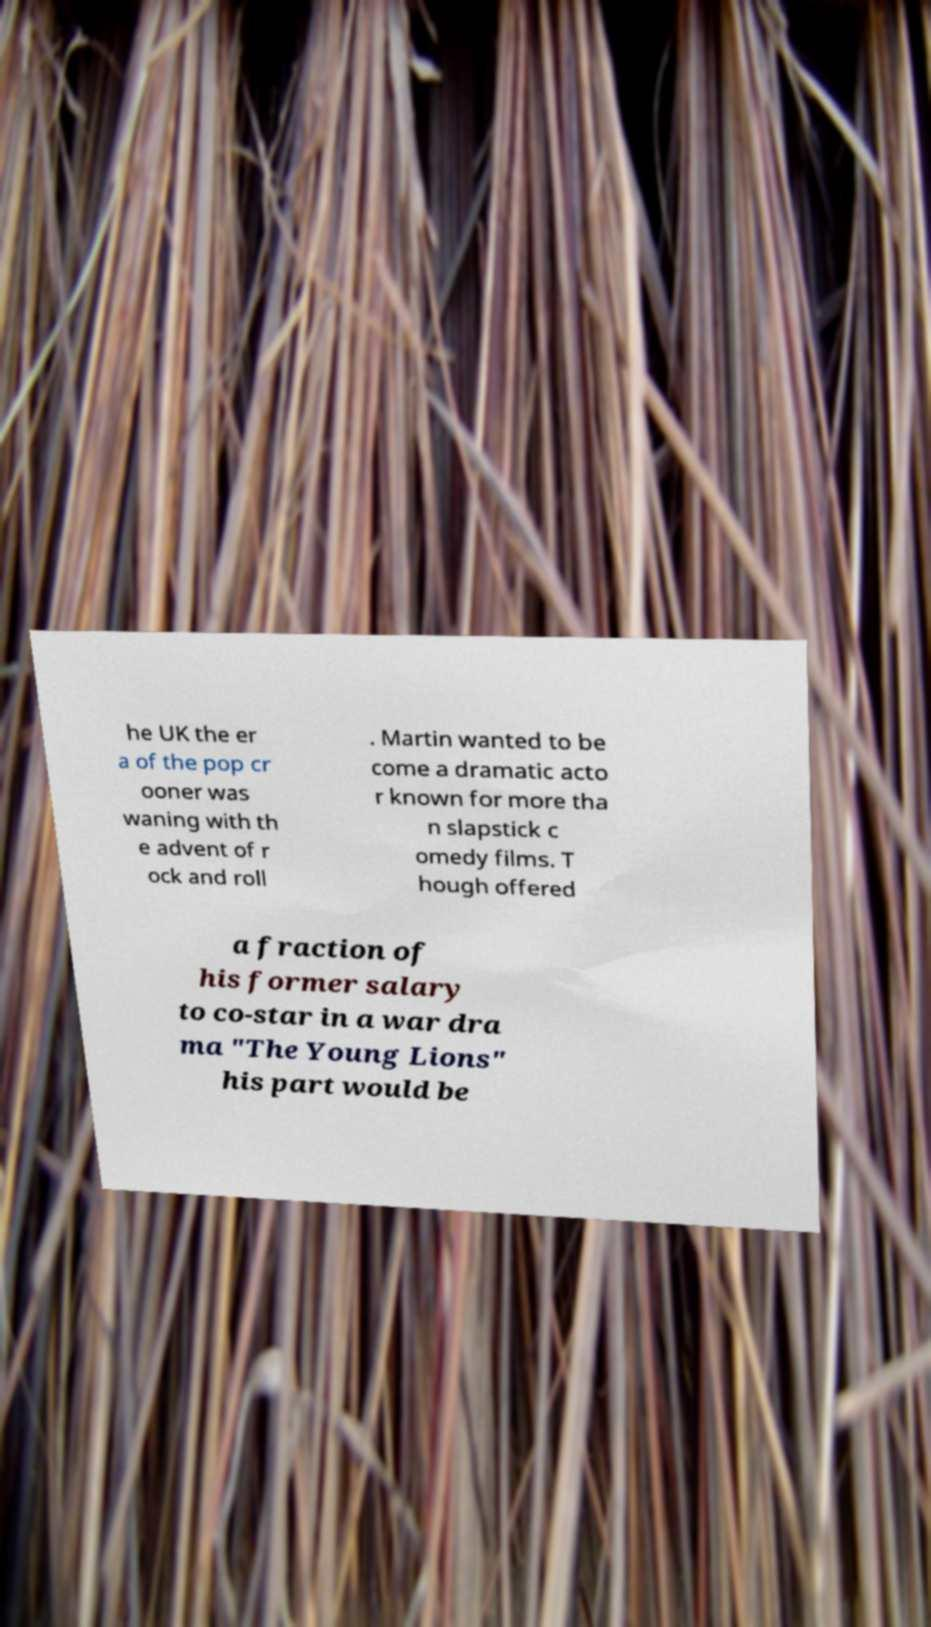Please read and relay the text visible in this image. What does it say? he UK the er a of the pop cr ooner was waning with th e advent of r ock and roll . Martin wanted to be come a dramatic acto r known for more tha n slapstick c omedy films. T hough offered a fraction of his former salary to co-star in a war dra ma "The Young Lions" his part would be 